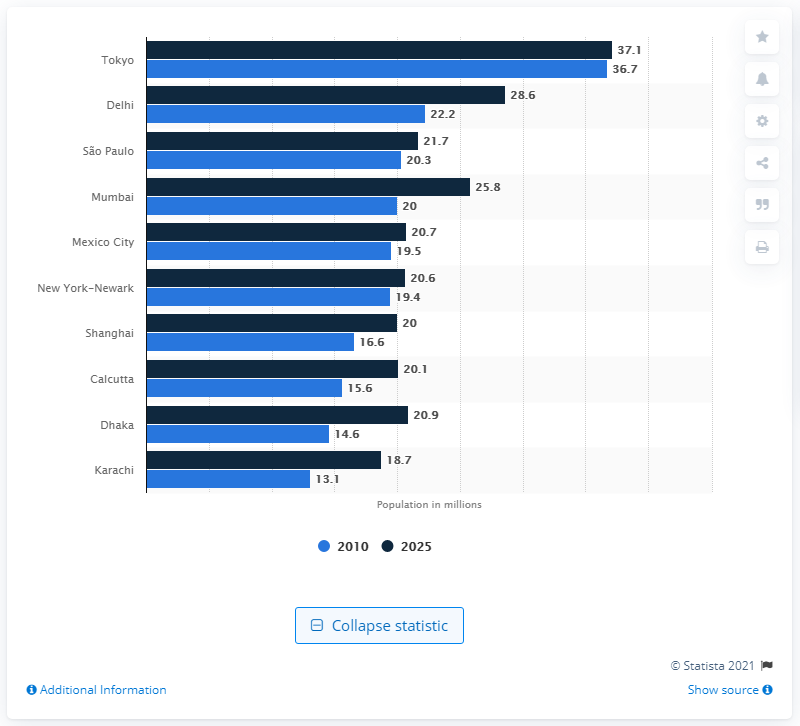Draw attention to some important aspects in this diagram. In 2010, the population of Tokyo was approximately 36.7 million people. 